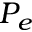Convert formula to latex. <formula><loc_0><loc_0><loc_500><loc_500>P _ { e }</formula> 